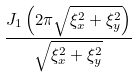Convert formula to latex. <formula><loc_0><loc_0><loc_500><loc_500>\frac { J _ { 1 } \left ( 2 \pi { \sqrt { \xi _ { x } ^ { 2 } + \xi _ { y } ^ { 2 } } } \right ) } { \sqrt { \xi _ { x } ^ { 2 } + \xi _ { y } ^ { 2 } } }</formula> 